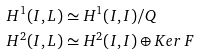<formula> <loc_0><loc_0><loc_500><loc_500>H ^ { 1 } ( I , L ) & \simeq H ^ { 1 } ( I , I ) / Q \\ H ^ { 2 } ( I , L ) & \simeq H ^ { 2 } ( I , I ) \oplus K e r \, F</formula> 